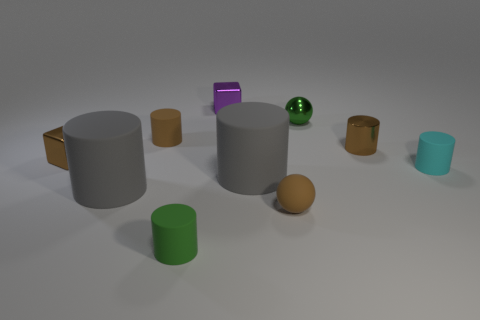What can you infer about the positions of these objects? Do they seem random or intentionally placed? The objects appear to be intentionally placed with strategic spacing between them. They form a rough semicircle, suggesting a designed arrangement to showcase variety in geometry and size.  Are these objects arranged in any particular pattern based on their color? Not precisely, but there is a noticeable variation of colors, from warm to cool tones, spread out across the objects, which adds visual interest and balance without a strict pattern. 